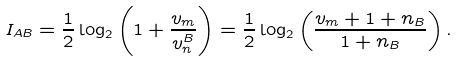<formula> <loc_0><loc_0><loc_500><loc_500>I _ { A B } = \frac { 1 } { 2 } \log _ { 2 } \left ( 1 + \frac { v _ { m } } { v ^ { B } _ { n } } \right ) = \frac { 1 } { 2 } \log _ { 2 } \left ( \frac { v _ { m } + 1 + n _ { B } } { 1 + n _ { B } } \right ) .</formula> 